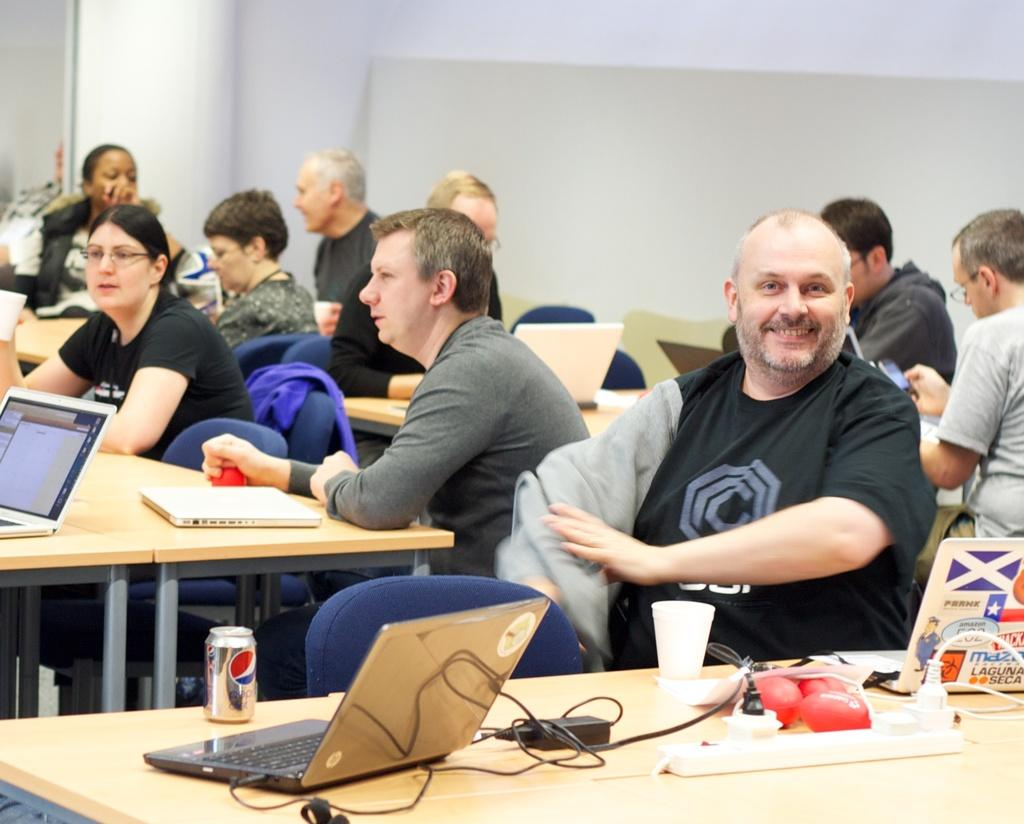What are the people in the image doing? There is a group of people sitting on chairs. What electronic device is on the table? There is a laptop on the table. What is connected to the laptop? There is a cable on the table. What else can be found on the table? There is a tin and glasses on the table. What type of sticks are being used in the image? There are no sticks present in the image. 